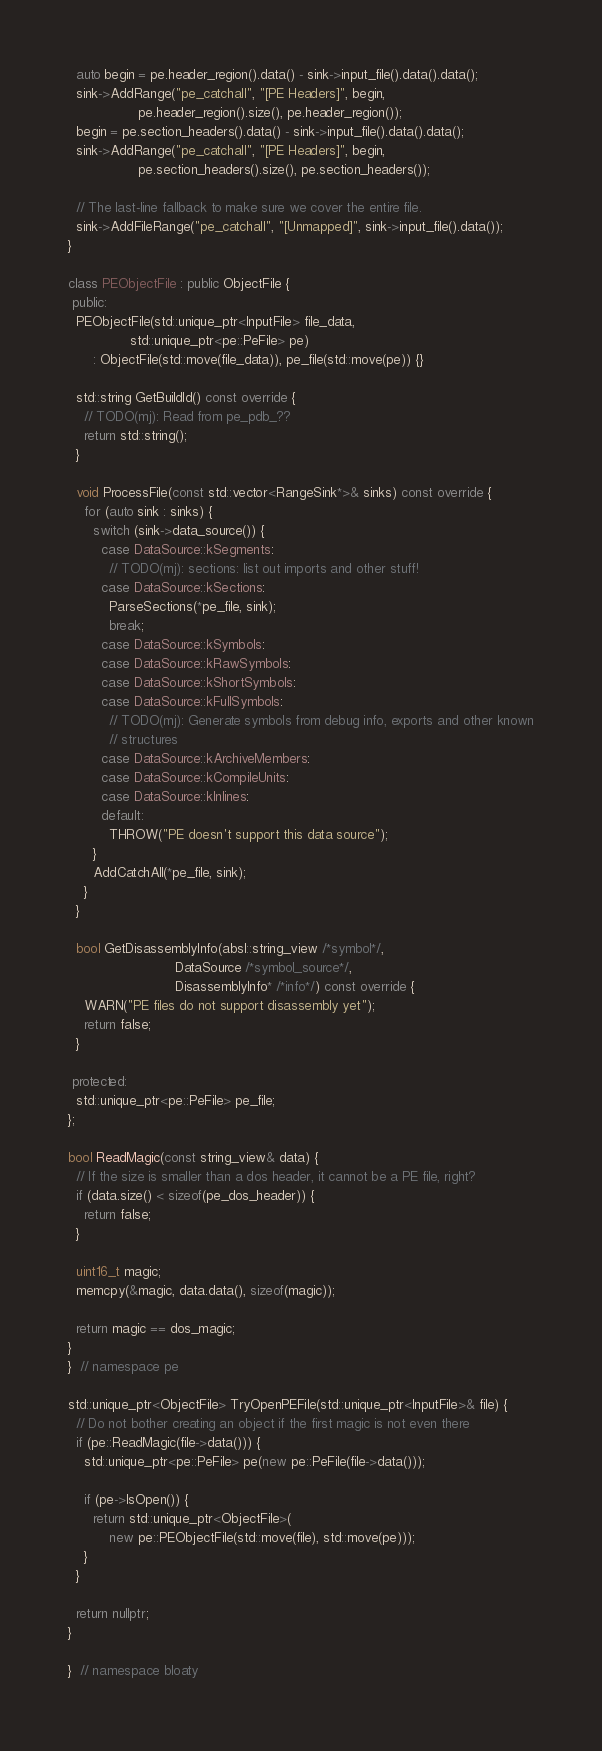Convert code to text. <code><loc_0><loc_0><loc_500><loc_500><_C++_>  auto begin = pe.header_region().data() - sink->input_file().data().data();
  sink->AddRange("pe_catchall", "[PE Headers]", begin,
                 pe.header_region().size(), pe.header_region());
  begin = pe.section_headers().data() - sink->input_file().data().data();
  sink->AddRange("pe_catchall", "[PE Headers]", begin,
                 pe.section_headers().size(), pe.section_headers());

  // The last-line fallback to make sure we cover the entire file.
  sink->AddFileRange("pe_catchall", "[Unmapped]", sink->input_file().data());
}

class PEObjectFile : public ObjectFile {
 public:
  PEObjectFile(std::unique_ptr<InputFile> file_data,
               std::unique_ptr<pe::PeFile> pe)
      : ObjectFile(std::move(file_data)), pe_file(std::move(pe)) {}

  std::string GetBuildId() const override {
    // TODO(mj): Read from pe_pdb_??
    return std::string();
  }

  void ProcessFile(const std::vector<RangeSink*>& sinks) const override {
    for (auto sink : sinks) {
      switch (sink->data_source()) {
        case DataSource::kSegments:
          // TODO(mj): sections: list out imports and other stuff!
        case DataSource::kSections:
          ParseSections(*pe_file, sink);
          break;
        case DataSource::kSymbols:
        case DataSource::kRawSymbols:
        case DataSource::kShortSymbols:
        case DataSource::kFullSymbols:
          // TODO(mj): Generate symbols from debug info, exports and other known
          // structures
        case DataSource::kArchiveMembers:
        case DataSource::kCompileUnits:
        case DataSource::kInlines:
        default:
          THROW("PE doesn't support this data source");
      }
      AddCatchAll(*pe_file, sink);
    }
  }

  bool GetDisassemblyInfo(absl::string_view /*symbol*/,
                          DataSource /*symbol_source*/,
                          DisassemblyInfo* /*info*/) const override {
    WARN("PE files do not support disassembly yet");
    return false;
  }

 protected:
  std::unique_ptr<pe::PeFile> pe_file;
};

bool ReadMagic(const string_view& data) {
  // If the size is smaller than a dos header, it cannot be a PE file, right?
  if (data.size() < sizeof(pe_dos_header)) {
    return false;
  }

  uint16_t magic;
  memcpy(&magic, data.data(), sizeof(magic));

  return magic == dos_magic;
}
}  // namespace pe

std::unique_ptr<ObjectFile> TryOpenPEFile(std::unique_ptr<InputFile>& file) {
  // Do not bother creating an object if the first magic is not even there
  if (pe::ReadMagic(file->data())) {
    std::unique_ptr<pe::PeFile> pe(new pe::PeFile(file->data()));

    if (pe->IsOpen()) {
      return std::unique_ptr<ObjectFile>(
          new pe::PEObjectFile(std::move(file), std::move(pe)));
    }
  }

  return nullptr;
}

}  // namespace bloaty
</code> 